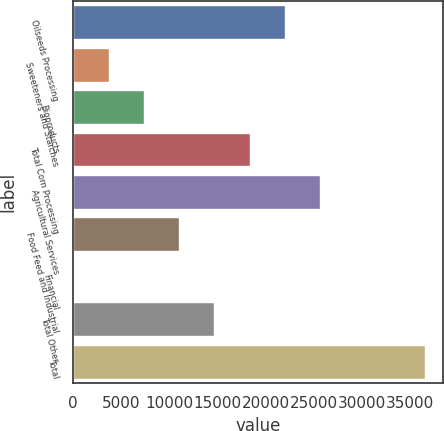<chart> <loc_0><loc_0><loc_500><loc_500><bar_chart><fcel>Oilseeds Processing<fcel>Sweeteners and Starches<fcel>Bioproducts<fcel>Total Corn Processing<fcel>Agricultural Services<fcel>Food Feed and Industrial<fcel>Financial<fcel>Total Other<fcel>Total<nl><fcel>21987.6<fcel>3727.1<fcel>7379.2<fcel>18335.5<fcel>25639.7<fcel>11031.3<fcel>75<fcel>14683.4<fcel>36596<nl></chart> 